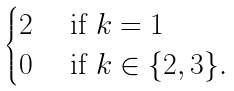Convert formula to latex. <formula><loc_0><loc_0><loc_500><loc_500>\begin{cases} 2 & \text { if } k = 1 \\ 0 & \text { if } k \in \{ 2 , 3 \} . \end{cases}</formula> 